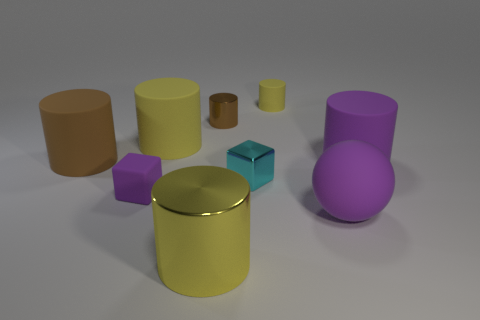There is a matte block that is the same color as the large rubber sphere; what size is it?
Your answer should be very brief. Small. The large matte thing that is the same color as the big sphere is what shape?
Keep it short and to the point. Cylinder. Do the yellow cylinder to the left of the big metallic cylinder and the metallic cylinder that is behind the brown rubber cylinder have the same size?
Your response must be concise. No. There is a big thing that is left of the small matte cylinder and in front of the big purple matte cylinder; what shape is it?
Offer a very short reply. Cylinder. Are there any cyan balls made of the same material as the small cyan cube?
Your response must be concise. No. What material is the large object that is the same color as the small shiny cylinder?
Give a very brief answer. Rubber. Are the yellow thing in front of the brown rubber cylinder and the tiny thing in front of the small cyan shiny cube made of the same material?
Provide a short and direct response. No. Is the number of small green blocks greater than the number of big balls?
Your answer should be compact. No. The small matte thing that is behind the purple thing to the left of the rubber object that is in front of the tiny purple thing is what color?
Provide a succinct answer. Yellow. Does the metallic cylinder that is in front of the purple cylinder have the same color as the tiny cube that is in front of the metal block?
Offer a very short reply. No. 